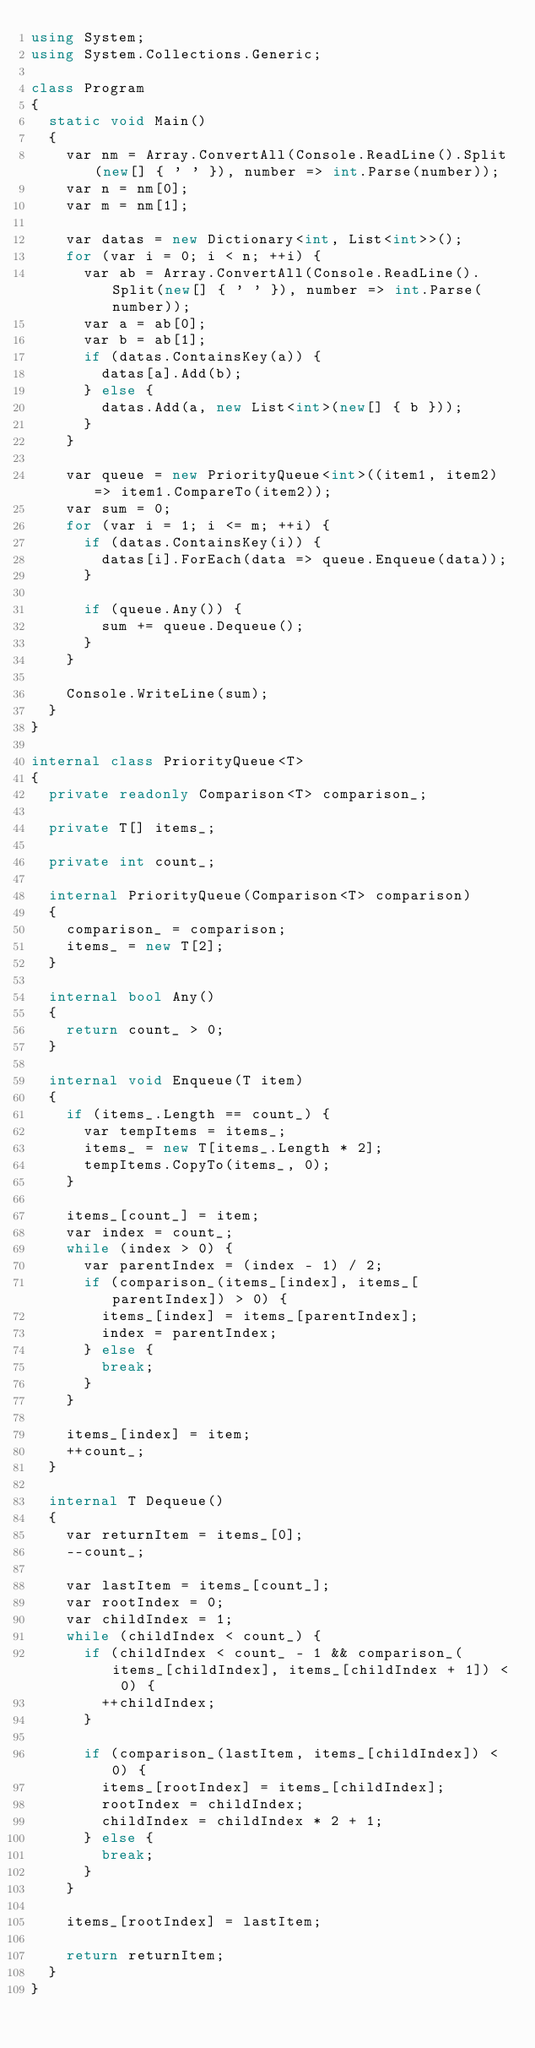Convert code to text. <code><loc_0><loc_0><loc_500><loc_500><_C#_>using System;
using System.Collections.Generic;

class Program
{
	static void Main()
	{
		var nm = Array.ConvertAll(Console.ReadLine().Split(new[] { ' ' }), number => int.Parse(number));
		var n = nm[0];
		var m = nm[1];

		var datas = new Dictionary<int, List<int>>();
		for (var i = 0; i < n; ++i) {
			var ab = Array.ConvertAll(Console.ReadLine().Split(new[] { ' ' }), number => int.Parse(number));
			var a = ab[0];
			var b = ab[1];
			if (datas.ContainsKey(a)) {
				datas[a].Add(b);
			} else {
				datas.Add(a, new List<int>(new[] { b }));
			}
		}

		var queue = new PriorityQueue<int>((item1, item2) => item1.CompareTo(item2));
		var sum = 0;
		for (var i = 1; i <= m; ++i) {
			if (datas.ContainsKey(i)) {
				datas[i].ForEach(data => queue.Enqueue(data));
			}

			if (queue.Any()) {
				sum += queue.Dequeue();
			}
		}

		Console.WriteLine(sum);
	}
}

internal class PriorityQueue<T>
{
	private readonly Comparison<T> comparison_;

	private T[] items_;

	private int count_;

	internal PriorityQueue(Comparison<T> comparison)
	{
		comparison_ = comparison;
		items_ = new T[2];
	}

	internal bool Any()
	{
		return count_ > 0;
	}

	internal void Enqueue(T item)
	{
		if (items_.Length == count_) {
			var tempItems = items_;
			items_ = new T[items_.Length * 2];
			tempItems.CopyTo(items_, 0);
		}

		items_[count_] = item;
		var index = count_;
		while (index > 0) {
			var parentIndex = (index - 1) / 2;
			if (comparison_(items_[index], items_[parentIndex]) > 0) {
				items_[index] = items_[parentIndex];
				index = parentIndex;
			} else {
				break;
			}
		}

		items_[index] = item;
		++count_;
	}

	internal T Dequeue()
	{
		var returnItem = items_[0];
		--count_;

		var lastItem = items_[count_];
		var rootIndex = 0;
		var childIndex = 1;
		while (childIndex < count_) {
			if (childIndex < count_ - 1 && comparison_(items_[childIndex], items_[childIndex + 1]) < 0) {
				++childIndex;
			}

			if (comparison_(lastItem, items_[childIndex]) < 0) {
				items_[rootIndex] = items_[childIndex];
				rootIndex = childIndex;
				childIndex = childIndex * 2 + 1;
			} else {
				break;
			}
		}

		items_[rootIndex] = lastItem;

		return returnItem;
	}
}
</code> 